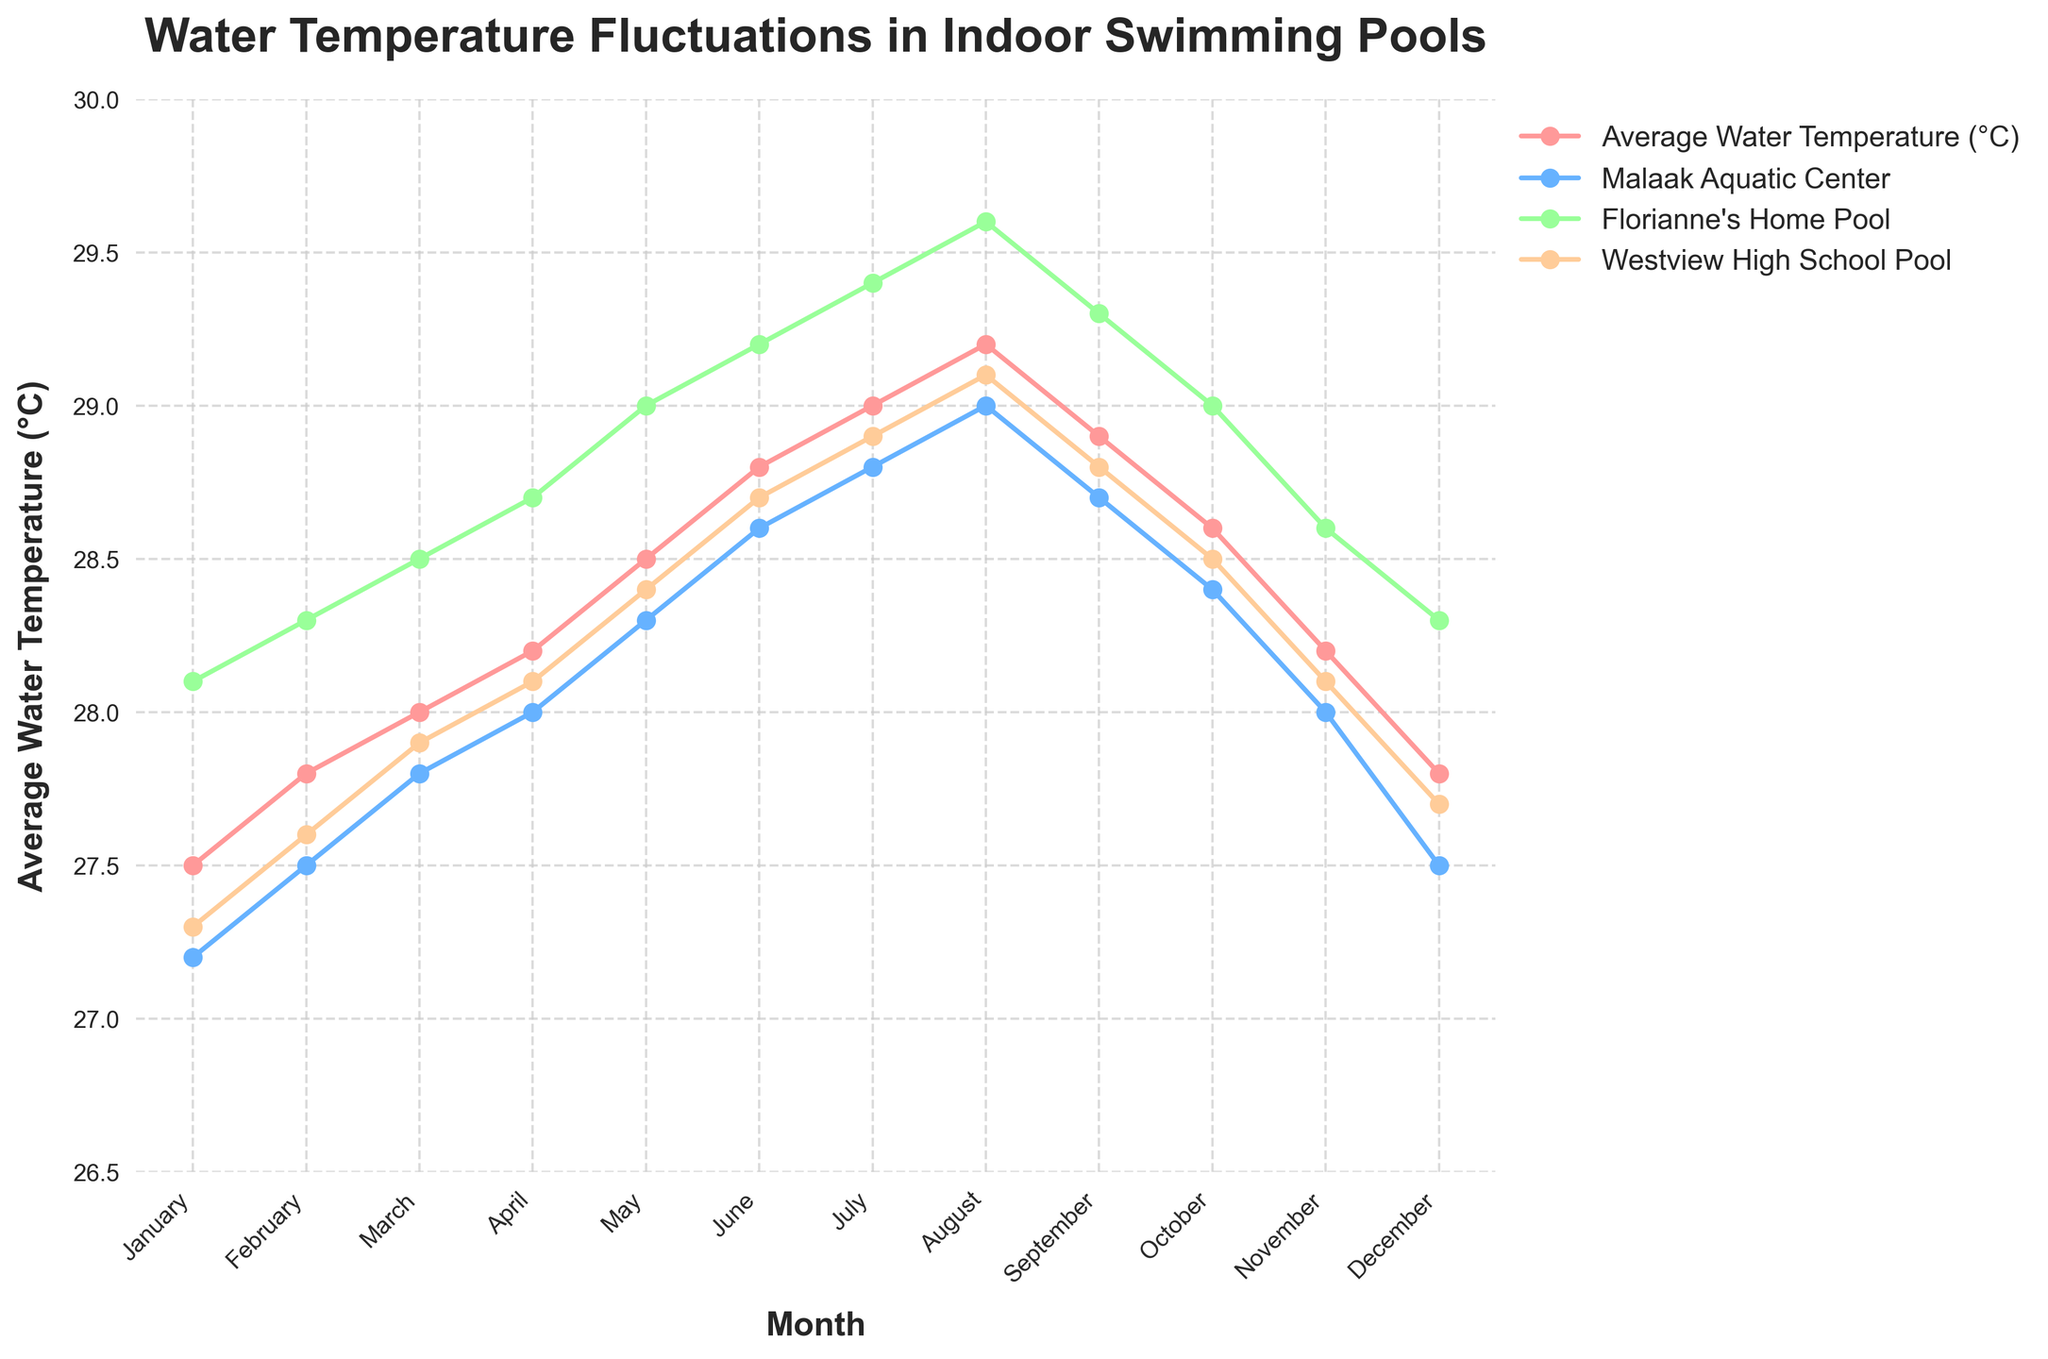What's the average water temperature in Florianne's Home Pool in the first quarter? To find the average for the first quarter (January, February, March), add the temperature values for these three months and then divide by 3. The values are 28.1, 28.3, and 28.5. The sum is 28.1 + 28.3 + 28.5 = 84.9. Dividing by 3, the average is 84.9 / 3 ≈ 28.3
Answer: 28.3°C Which month shows the highest average water temperature in Malaak Aquatic Center? Look at the Malaak Aquatic Center line and identify the highest point. The maximum temperature occurs in August at 29.0°C
Answer: August How does the average water temperature in July compare between Westview High School Pool and Malaak Aquatic Center? Check the temperature values for these two pools in July. Westview High School Pool has 28.9°C, and Malaak Aquatic Center has 28.8°C. Compare these values: 28.9°C > 28.8°C
Answer: Westview High School Pool is warmer In which months does the Malaak Aquatic Center have a higher temperature than the Average Water Temperature? Identify the months where the value for Malaak Aquatic Center exceeds the Average Water Temperature. This occurs in all months, as Malaak ranges from 27.2 to 29.0, surpassing the Average Water Temperature which ranges from 27.5 to 29.2.
Answer: Every month What is the temperature difference between the highest and lowest recorded values in Florianne's Home Pool? Identify the highest and lowest temperatures in Florianne’s Home Pool, which are 29.6°C and 28.1°C, respectively. The difference is calculated as 29.6 - 28.1 = 1.5°C
Answer: 1.5°C Which pool shows the smallest fluctuation in temperature over the year? Examine the range (the difference between the highest and lowest temperature) for each pool. Malaak's range is from 27.2°C to 29.0°C (1.8°C), Florianne's is 28.1°C to 29.6°C (1.5°C), and Westview's is 27.3°C to 29.1°C (1.8°C). Florianne's Home Pool has the smallest range (1.5°C).
Answer: Florianne's Home Pool What is the average water temperature in Westview High School Pool over the summer months (June, July, August)? Add the temperature values for June (28.7°C), July (28.9°C), and August (29.1°C). The sum is 28.7 + 28.9 + 29.1 = 86.7. Dividing by 3 gives the average: 86.7 / 3 ≈ 28.9°C
Answer: 28.9°C 